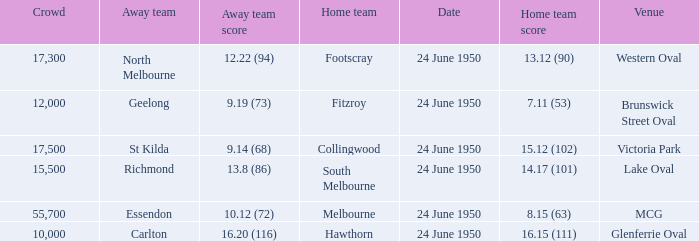Who was the host team for the match where north melbourne was the visiting team and the audience exceeded 12,000? Footscray. 